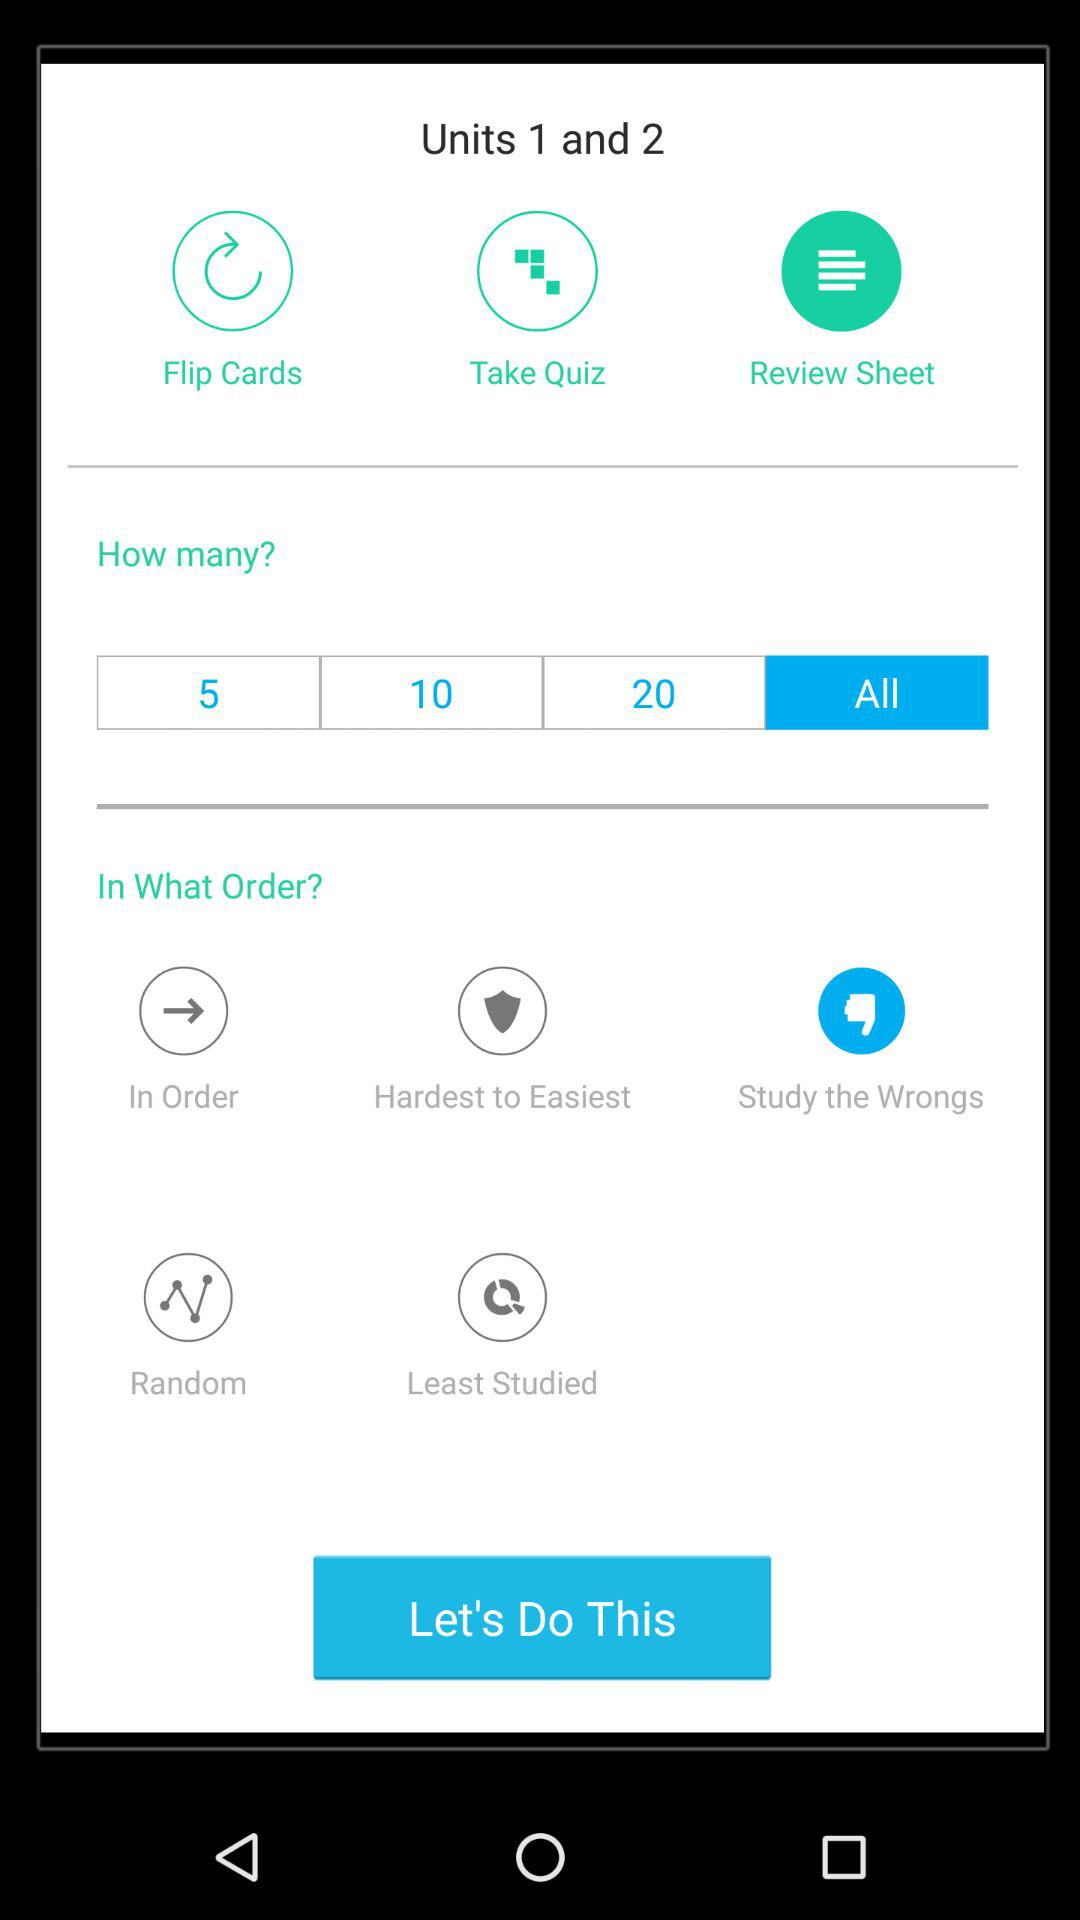What's the selected option in "In What Order?"? The selected option in "In What Order?" is "Study the Wrongs". 